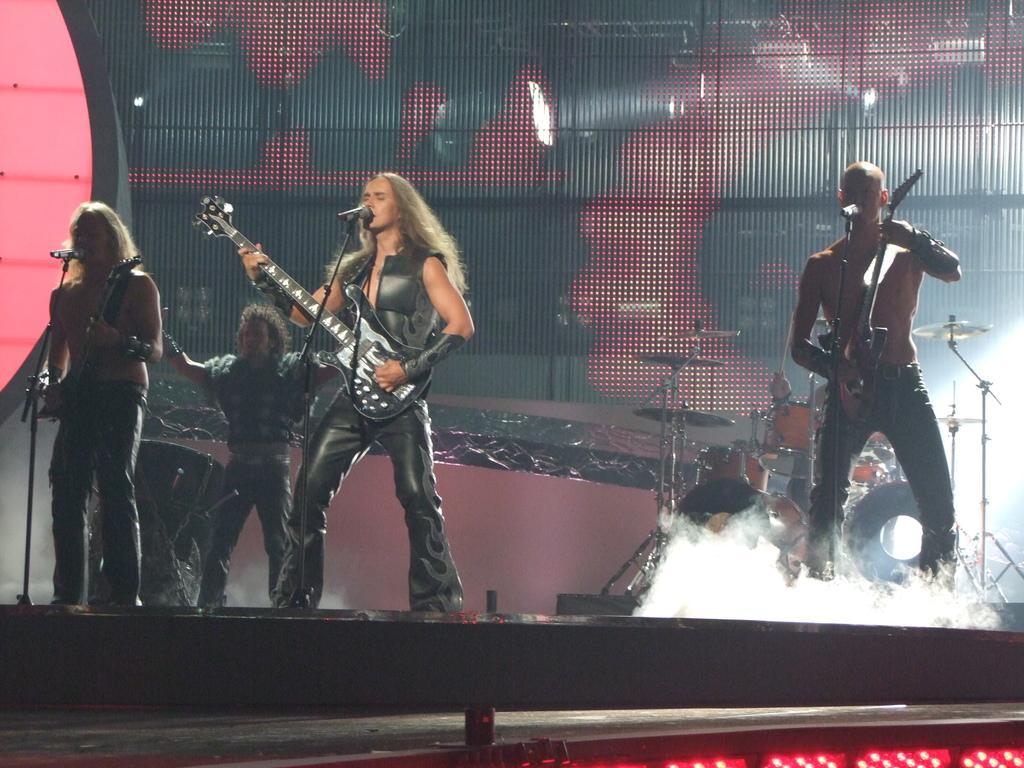Could you give a brief overview of what you see in this image? Here a person is standing and also singing a song. 